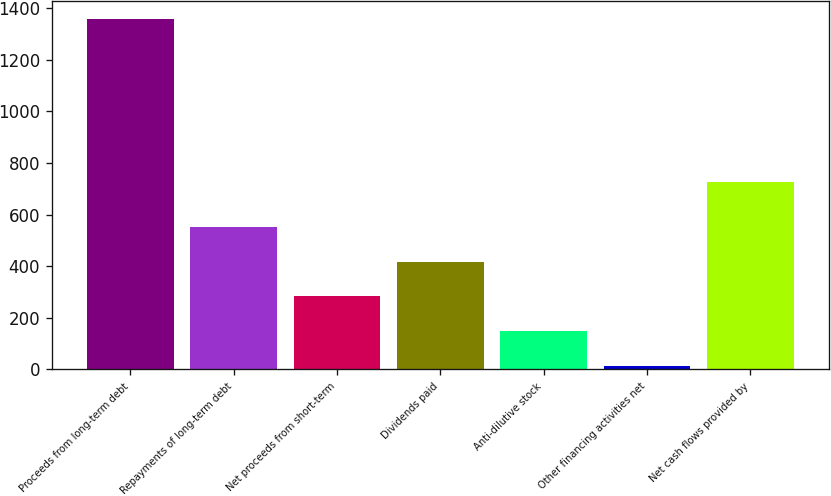Convert chart to OTSL. <chart><loc_0><loc_0><loc_500><loc_500><bar_chart><fcel>Proceeds from long-term debt<fcel>Repayments of long-term debt<fcel>Net proceeds from short-term<fcel>Dividends paid<fcel>Anti-dilutive stock<fcel>Other financing activities net<fcel>Net cash flows provided by<nl><fcel>1358<fcel>552.2<fcel>283.6<fcel>417.9<fcel>149.3<fcel>15<fcel>726<nl></chart> 